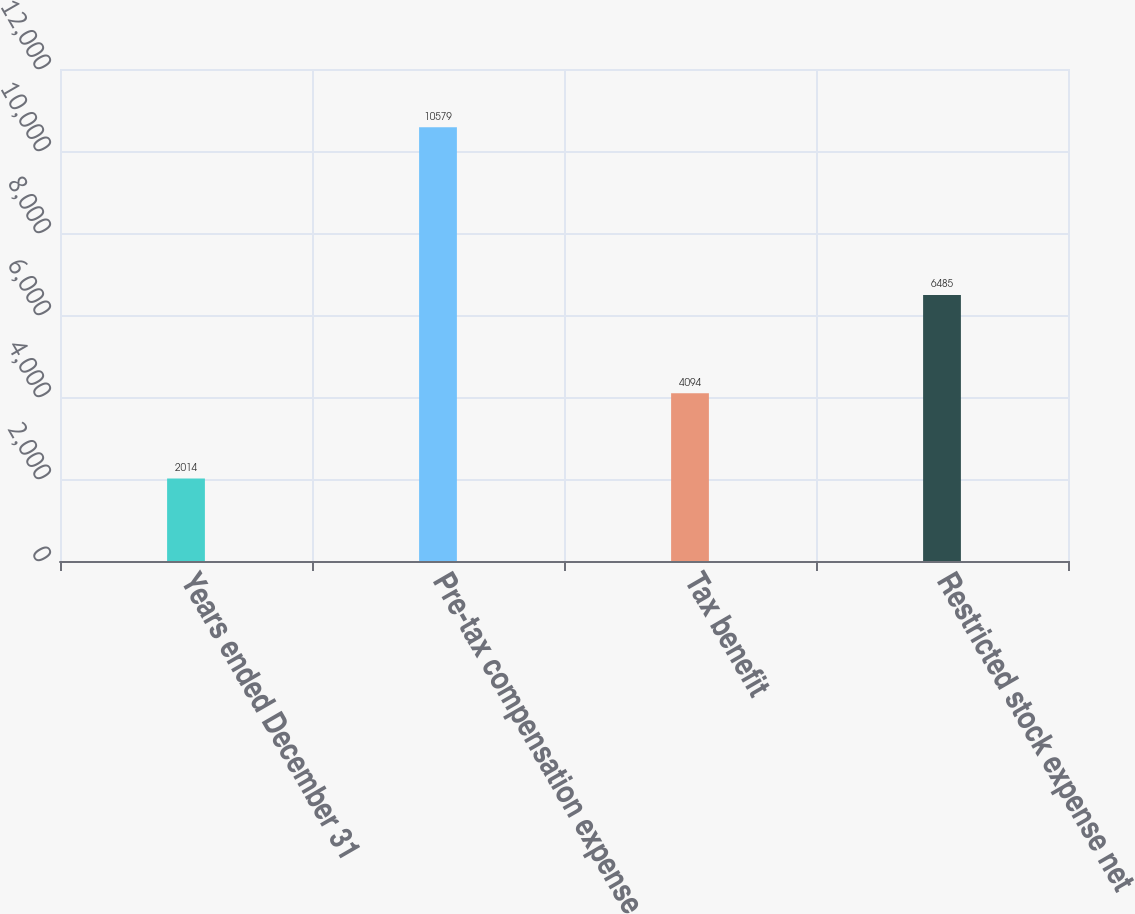Convert chart to OTSL. <chart><loc_0><loc_0><loc_500><loc_500><bar_chart><fcel>Years ended December 31<fcel>Pre-tax compensation expense<fcel>Tax benefit<fcel>Restricted stock expense net<nl><fcel>2014<fcel>10579<fcel>4094<fcel>6485<nl></chart> 